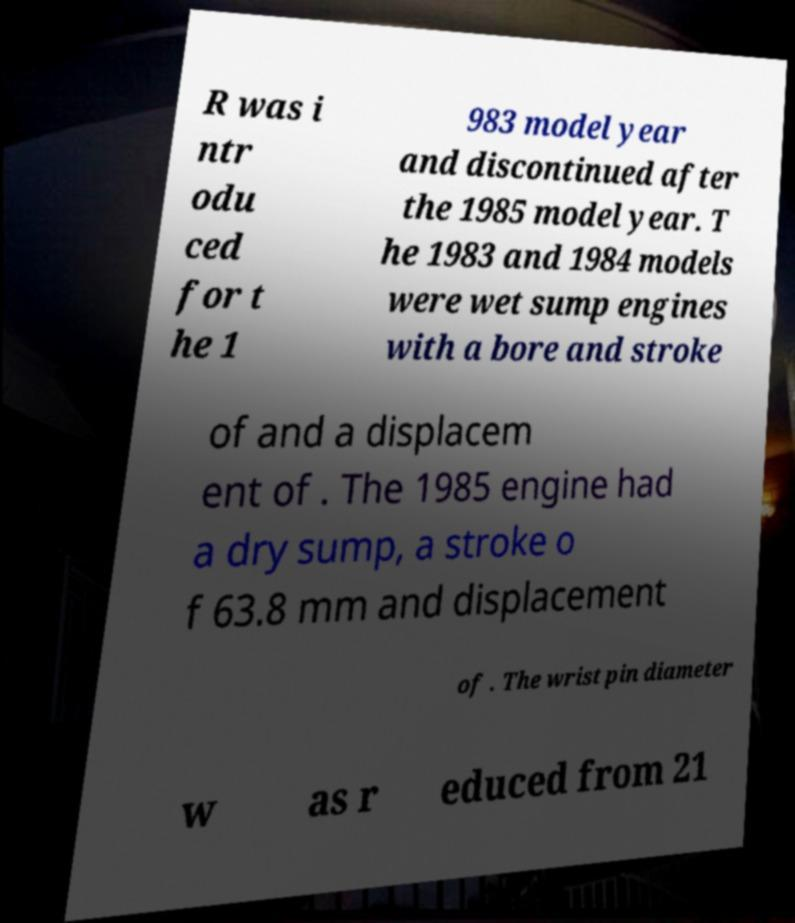There's text embedded in this image that I need extracted. Can you transcribe it verbatim? R was i ntr odu ced for t he 1 983 model year and discontinued after the 1985 model year. T he 1983 and 1984 models were wet sump engines with a bore and stroke of and a displacem ent of . The 1985 engine had a dry sump, a stroke o f 63.8 mm and displacement of . The wrist pin diameter w as r educed from 21 